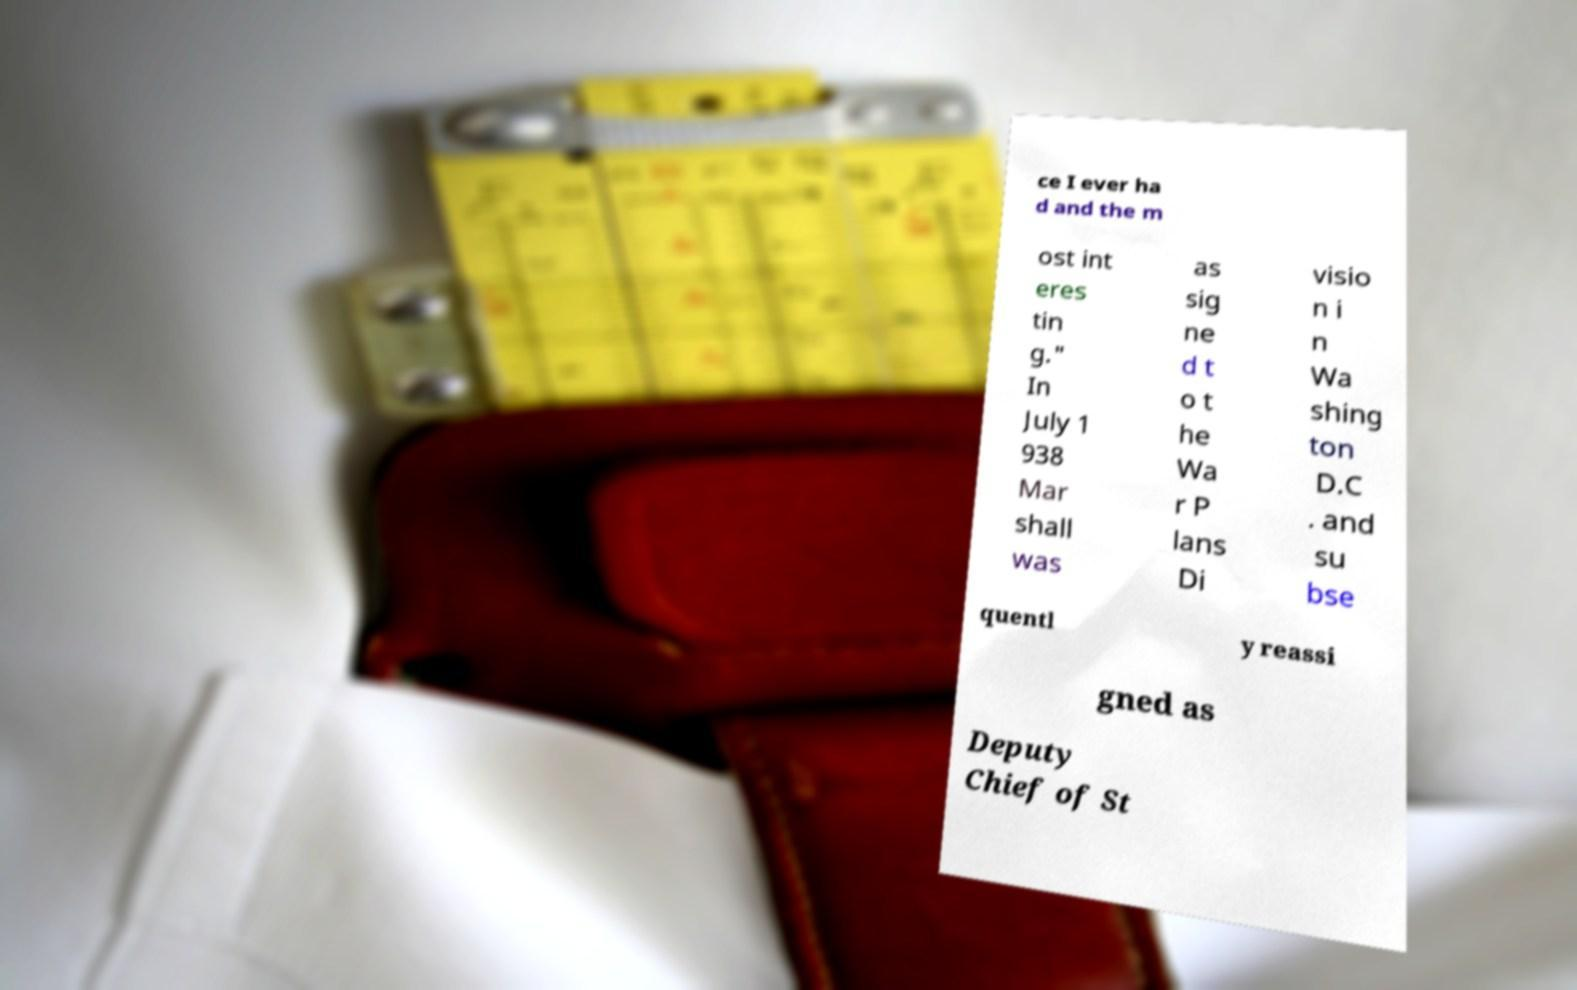Could you extract and type out the text from this image? ce I ever ha d and the m ost int eres tin g." In July 1 938 Mar shall was as sig ne d t o t he Wa r P lans Di visio n i n Wa shing ton D.C . and su bse quentl y reassi gned as Deputy Chief of St 